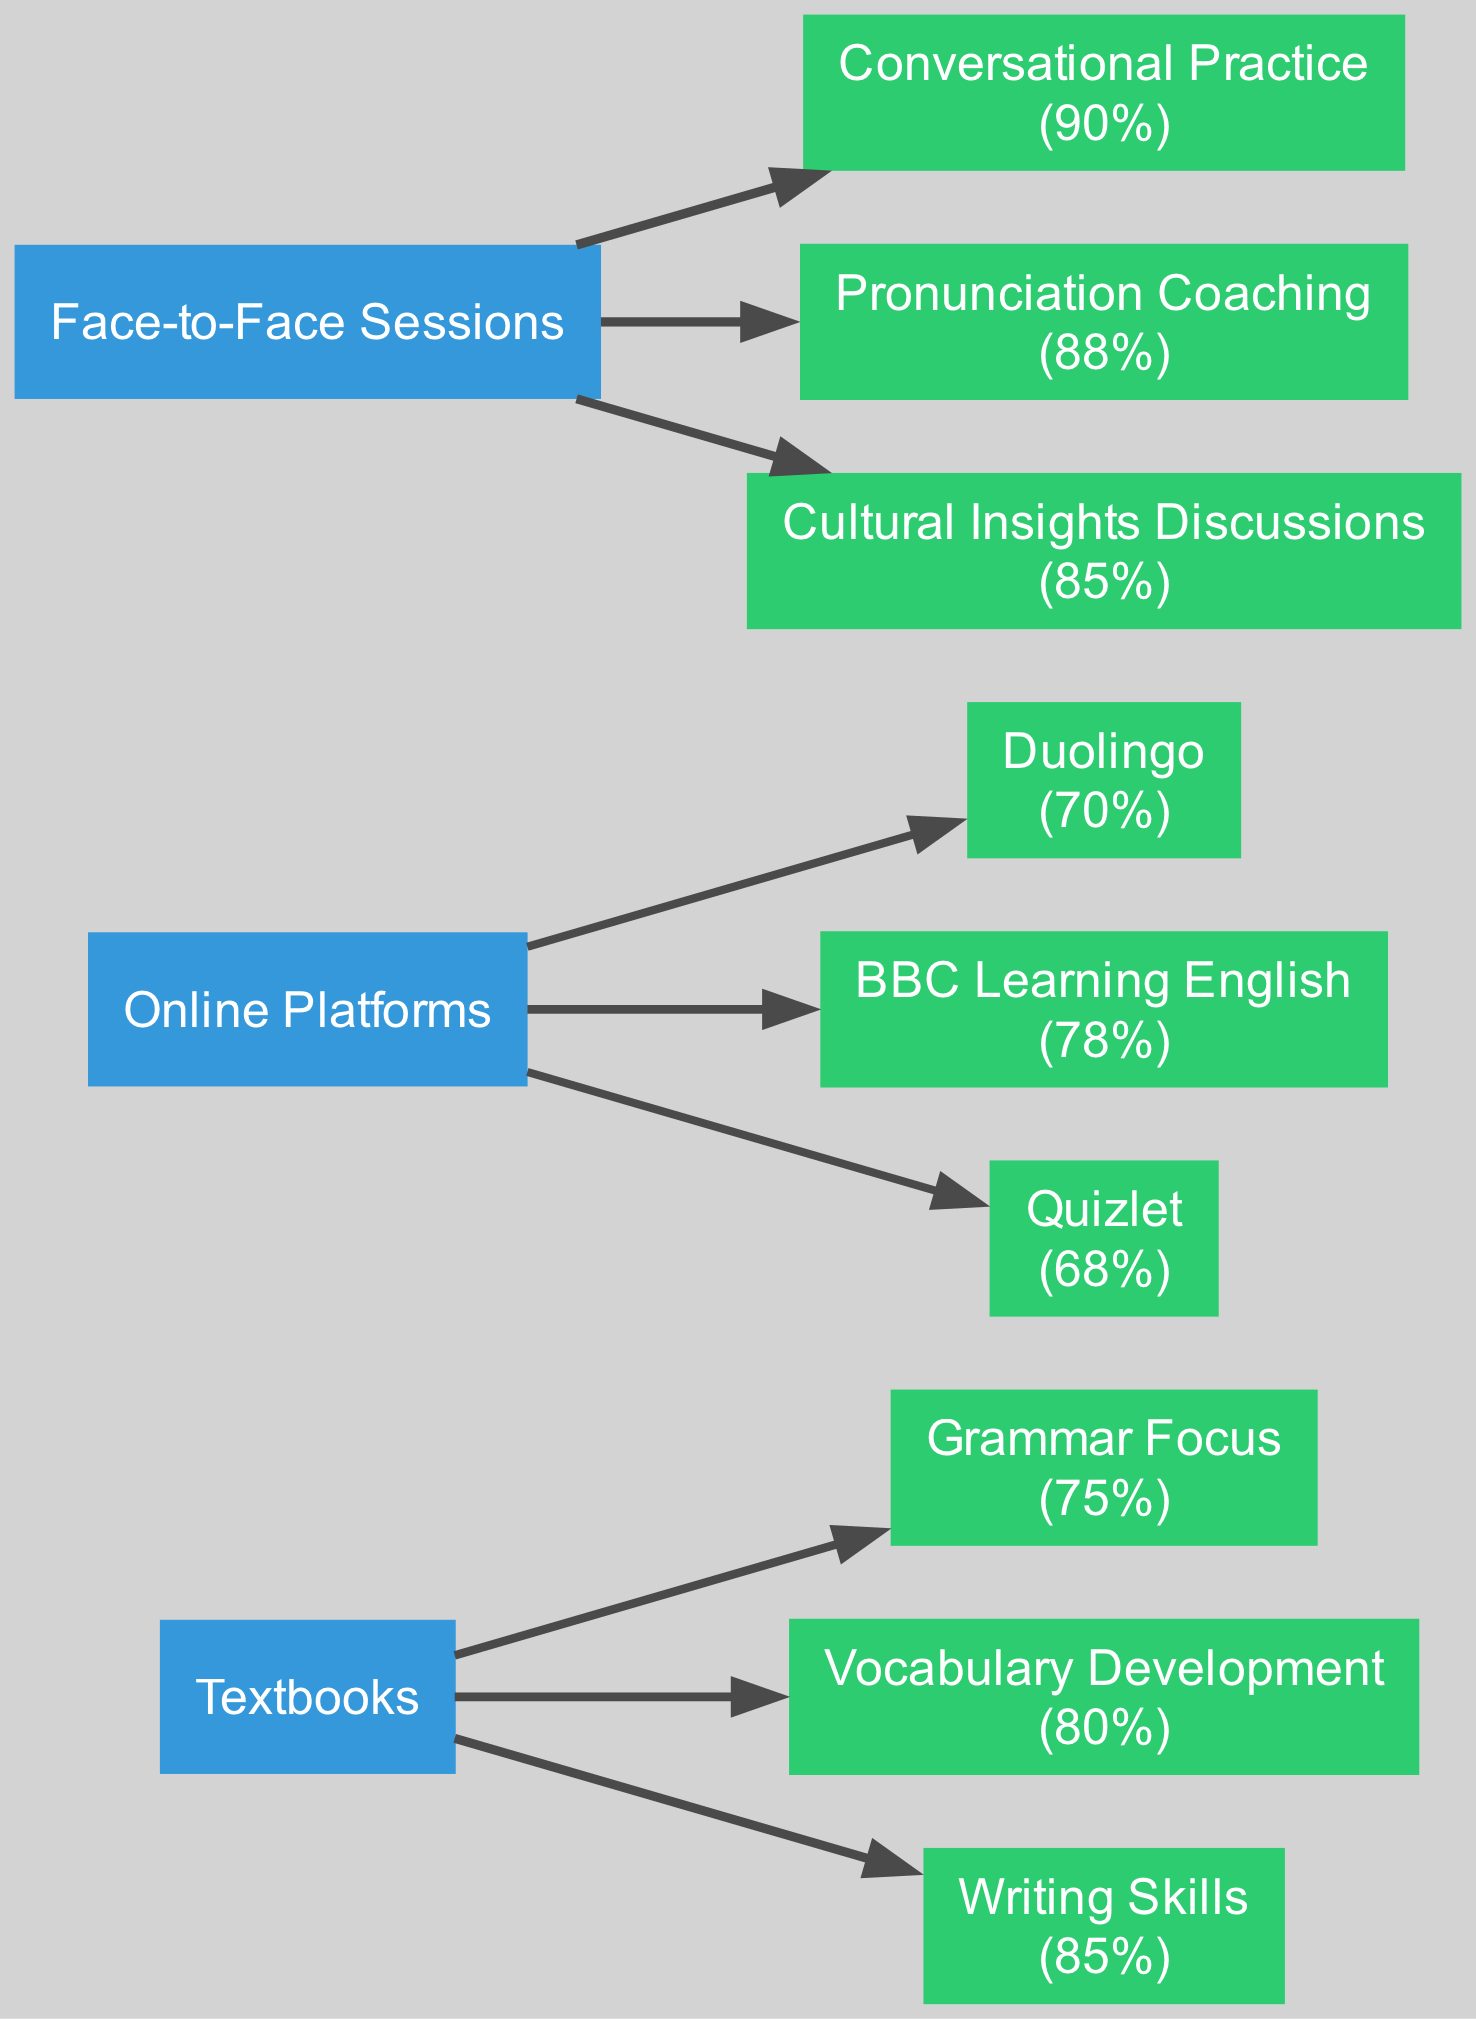What resource has the highest effectiveness? By examining the subcategories of all resources, "Conversational Practice" under "Face-to-Face Sessions," which has an effectiveness of 90%, is the highest among all the others.
Answer: Conversational Practice Which resource category has the lowest average effectiveness? To determine this, we calculate the average effectiveness for each resource: Textbooks (80%), Online Platforms (72.67%), Face-to-Face Sessions (87.67%). Online Platforms have the lowest average.
Answer: Online Platforms How many subcategories are there for textbooks? Looking at the diagram, "Textbooks" has three subcategories: Grammar Focus, Vocabulary Development, and Writing Skills. Therefore, the count is 3.
Answer: 3 What is the effectiveness of Vocabulary Development? The effectiveness of Vocabulary Development is specifically represented in the diagram as 80%.
Answer: 80% What is the total effectiveness score of Face-to-Face Sessions? The effectiveness for Face-to-Face Sessions includes: 90% (Conversational Practice) + 88% (Pronunciation Coaching) + 85% (Cultural Insights Discussions) totaling to 263%.
Answer: 263% Which resource has the second highest effectiveness score? After identifying the highest ("Conversational Practice") as 90%, the second highest can be determined as "Pronunciation Coaching" at 88%. Thus, the answer is "Pronunciation Coaching."
Answer: Pronunciation Coaching Which online platform is the least effective? Among the listed online platforms, Quizlet has the lowest effectiveness score of 68%.
Answer: Quizlet How many total nodes are present in the diagram? Counting all the resources and their subcategories, the total number of nodes adds up to 9 (3 resources and 6 subcategories).
Answer: 9 What is the effectiveness of Writing Skills? The effectiveness of Writing Skills is clearly indicated in the diagram as 85%.
Answer: 85% 